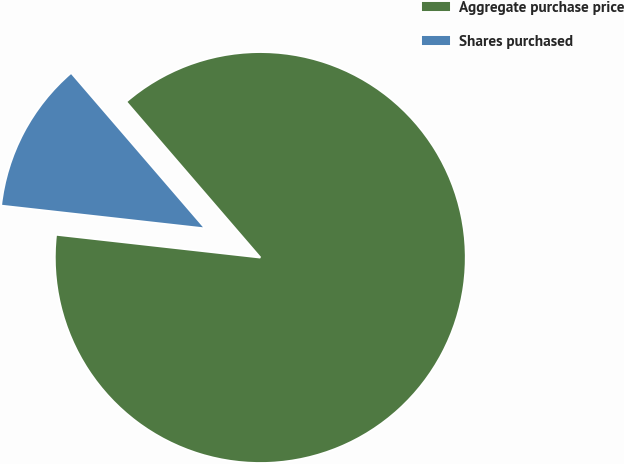Convert chart. <chart><loc_0><loc_0><loc_500><loc_500><pie_chart><fcel>Aggregate purchase price<fcel>Shares purchased<nl><fcel>88.09%<fcel>11.91%<nl></chart> 